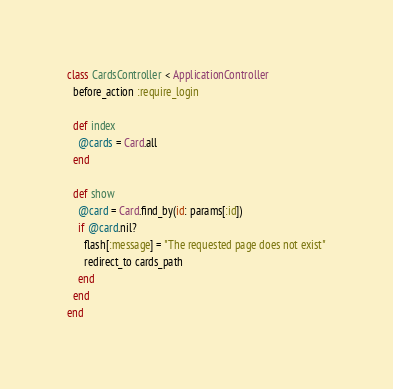Convert code to text. <code><loc_0><loc_0><loc_500><loc_500><_Ruby_>class CardsController < ApplicationController
  before_action :require_login

  def index
    @cards = Card.all
  end

  def show
    @card = Card.find_by(id: params[:id])
    if @card.nil?
      flash[:message] = "The requested page does not exist"
      redirect_to cards_path
    end
  end
end</code> 